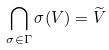<formula> <loc_0><loc_0><loc_500><loc_500>\bigcap _ { \sigma \in \Gamma } \sigma ( V ) = \widetilde { V }</formula> 